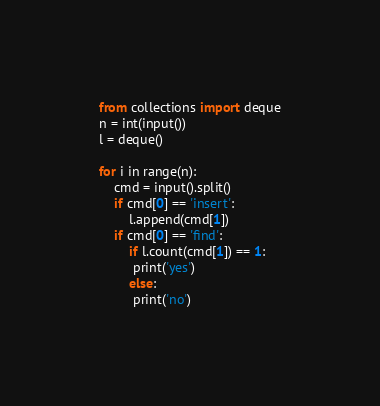Convert code to text. <code><loc_0><loc_0><loc_500><loc_500><_Python_>from collections import deque
n = int(input())
l = deque()

for i in range(n):
    cmd = input().split()
    if cmd[0] == 'insert':
        l.append(cmd[1])
    if cmd[0] == 'find':
        if l.count(cmd[1]) == 1:
         print('yes')
        else:
         print('no')</code> 